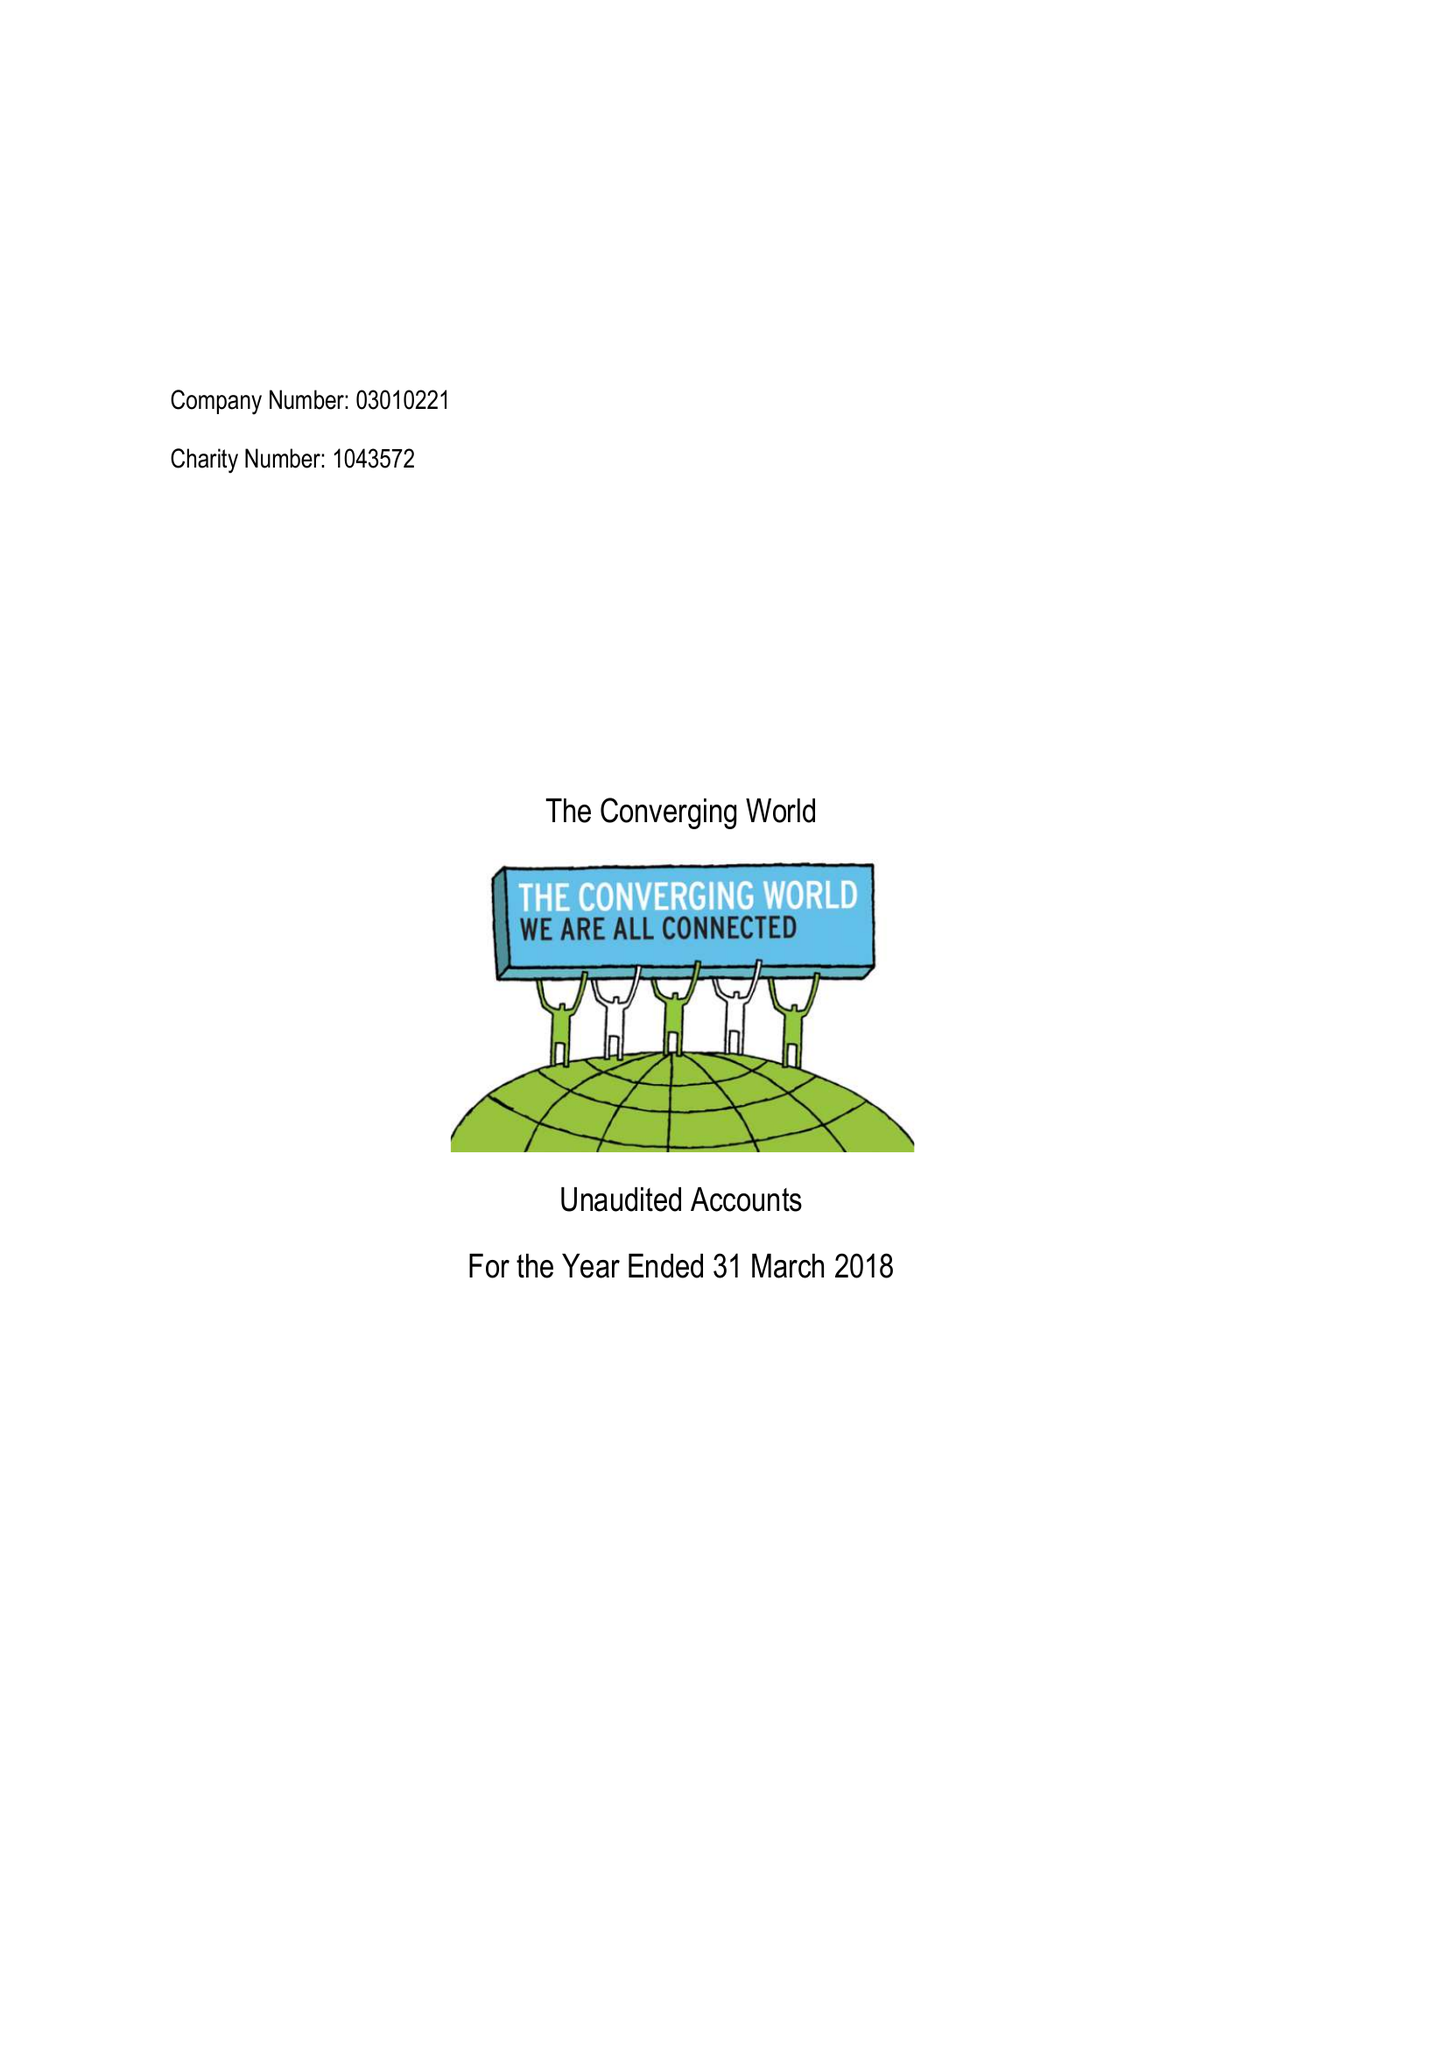What is the value for the charity_number?
Answer the question using a single word or phrase. 1043572 